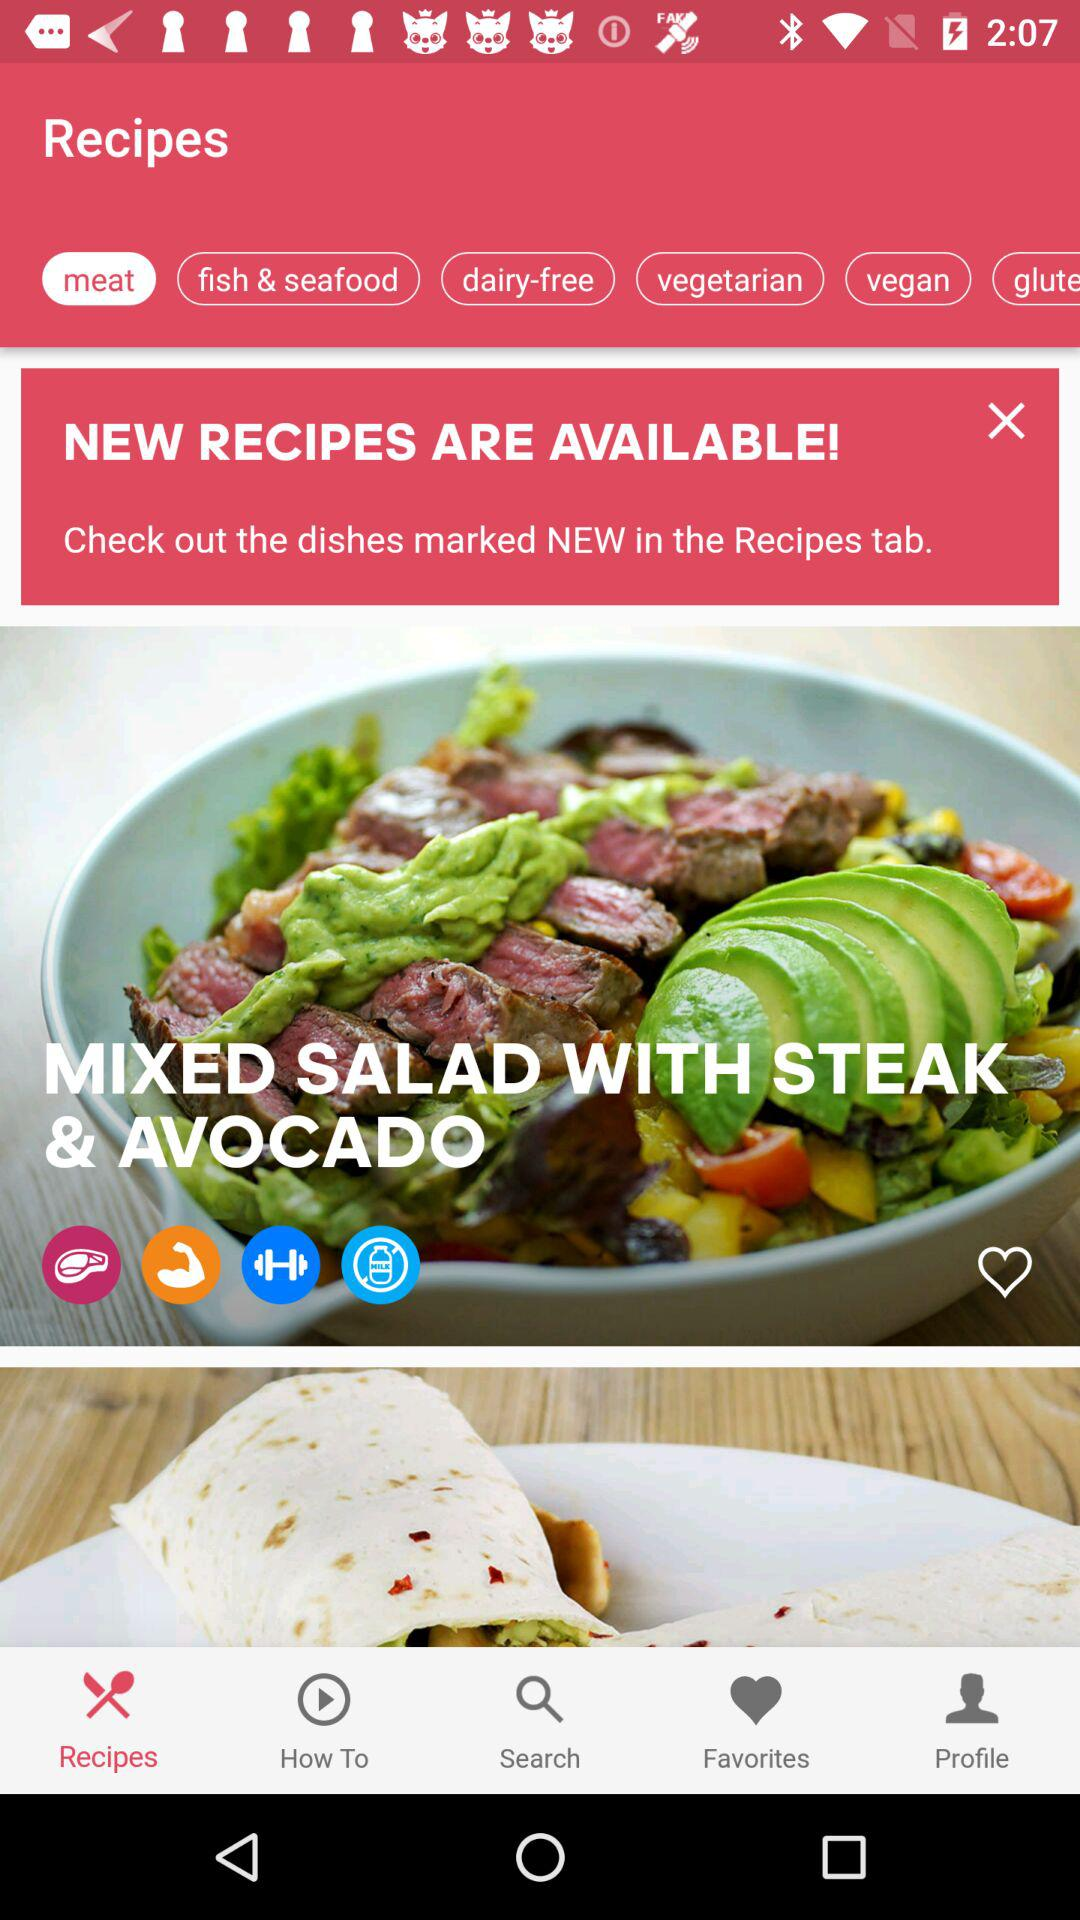Which tab is selected? The selected tab is "Recipes". 